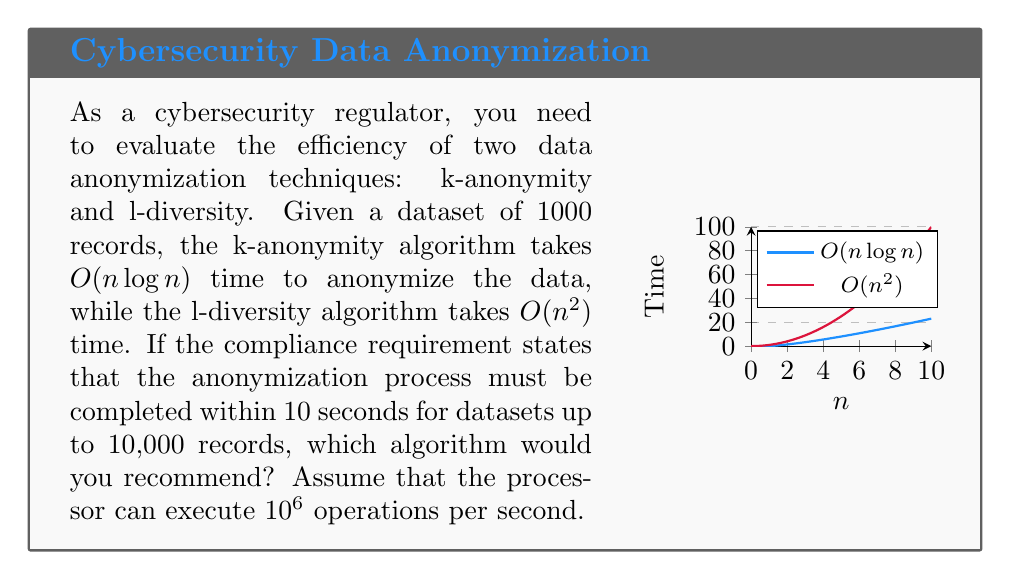What is the answer to this math problem? To evaluate the efficiency of the two algorithms, we need to:

1. Calculate the maximum number of operations allowed within 10 seconds:
   $10 \text{ seconds} \times 10^6 \text{ operations/second} = 10^7 \text{ operations}$

2. Express the time complexity of each algorithm in terms of operations:
   k-anonymity: $T_k(n) = c_1 n \log n$
   l-diversity: $T_l(n) = c_2 n^2$
   where $c_1$ and $c_2$ are constants

3. Find the maximum value of n for each algorithm that satisfies the 10-second constraint:

   For k-anonymity:
   $c_1 n \log n \leq 10^7$
   Assuming $c_1 = 1$ (best case), we get:
   $n \log n \leq 10^7$
   
   For l-diversity:
   $c_2 n^2 \leq 10^7$
   Assuming $c_2 = 1$ (best case), we get:
   $n^2 \leq 10^7$
   $n \leq \sqrt{10^7} \approx 3162$

4. Compare the maximum values of n with the required 10,000 records:
   k-anonymity: $n \log n \leq 10^7$ is satisfied for $n \approx 450,000 > 10,000$
   l-diversity: $n \leq 3162 < 10,000$

5. Conclusion:
   The k-anonymity algorithm can handle datasets much larger than 10,000 records within the 10-second time constraint, while the l-diversity algorithm falls short of the requirement.
Answer: k-anonymity algorithm 